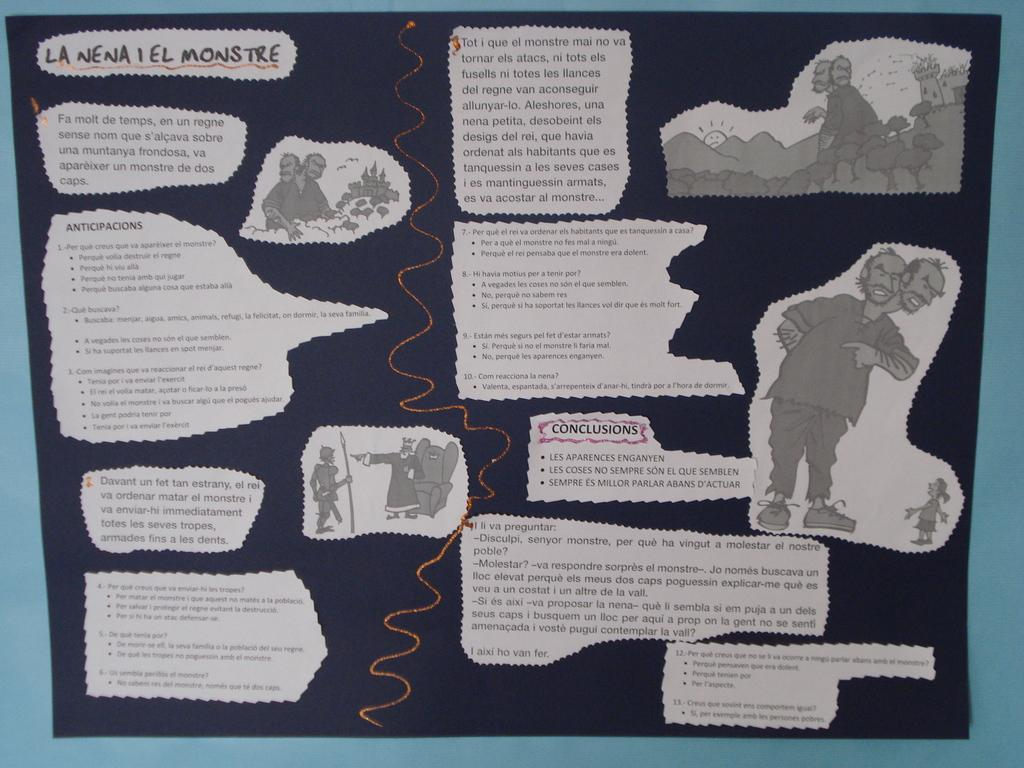What is the color of the paper in the image? The paper in the image is black. What is written or drawn on the paper? The paper has text and images on it. How is the paper displayed in the image? The paper is attached to the wall. Can you see a friend standing next to the giraffe in the image? There is no friend or giraffe present in the image; it only features a black paper with text and images. 